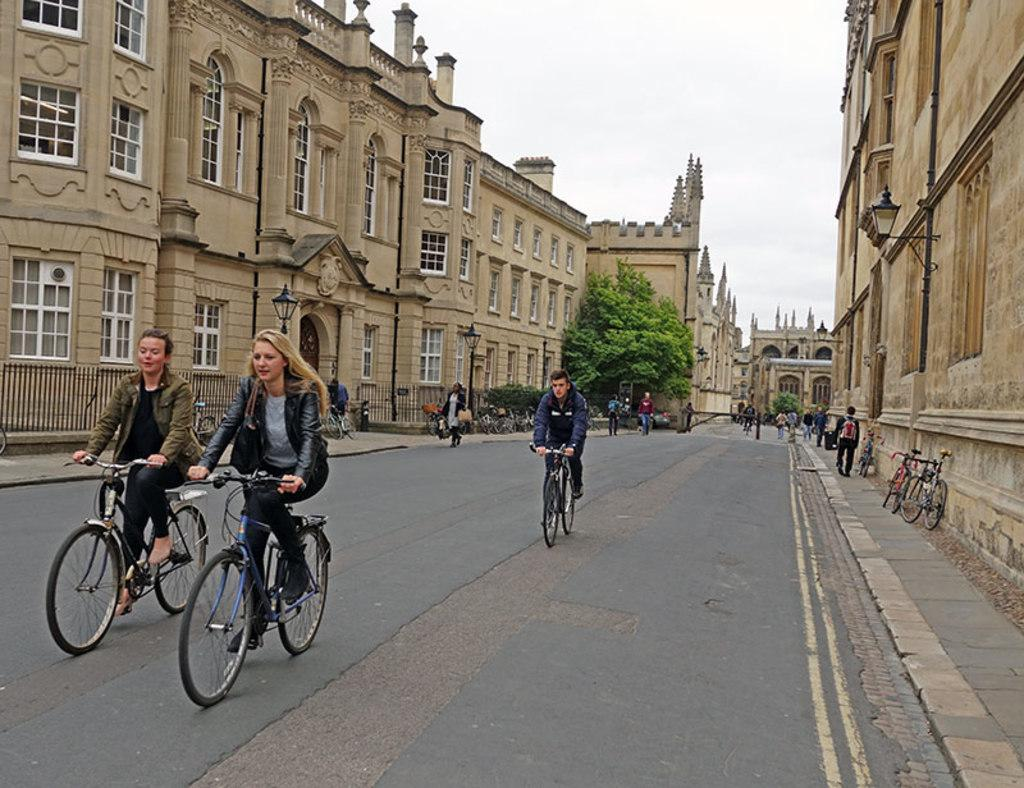What are the people in the image doing? There is a group of persons riding bicycles in the street. Can you describe any other objects or people in the background? In the background, there is a bicycle, a group of persons walking, a tree, a building, a light, a door, and the sky is visible. What type of roof can be seen on the bridge in the image? There is no bridge or roof present in the image. What impulse might have caused the group of persons to start walking in the background? The image does not provide information about the reasons or impulses behind the actions of the people in the image. 